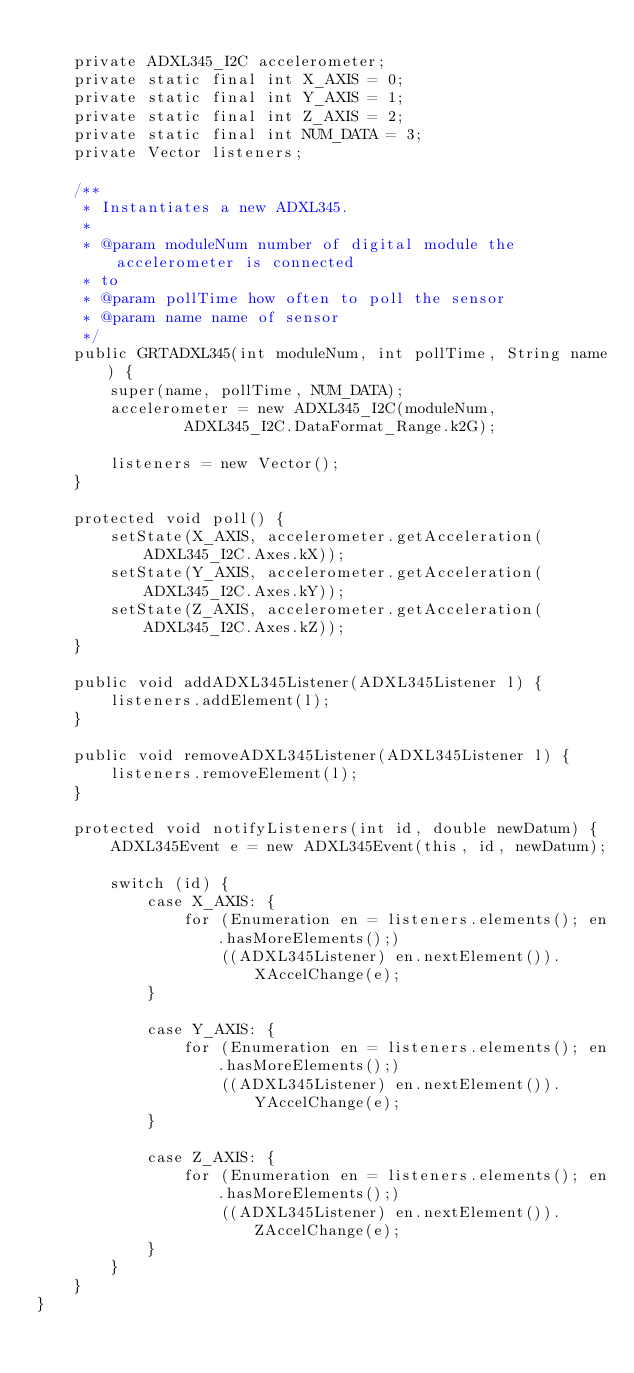<code> <loc_0><loc_0><loc_500><loc_500><_Java_>
    private ADXL345_I2C accelerometer;
    private static final int X_AXIS = 0;
    private static final int Y_AXIS = 1;
    private static final int Z_AXIS = 2;
    private static final int NUM_DATA = 3;
    private Vector listeners;

    /**
     * Instantiates a new ADXL345.
     *
     * @param moduleNum number of digital module the accelerometer is connected
     * to
     * @param pollTime how often to poll the sensor
     * @param name name of sensor
     */
    public GRTADXL345(int moduleNum, int pollTime, String name) {
        super(name, pollTime, NUM_DATA);
        accelerometer = new ADXL345_I2C(moduleNum,
                ADXL345_I2C.DataFormat_Range.k2G);

        listeners = new Vector();
    }

    protected void poll() {
        setState(X_AXIS, accelerometer.getAcceleration(ADXL345_I2C.Axes.kX));
        setState(Y_AXIS, accelerometer.getAcceleration(ADXL345_I2C.Axes.kY));
        setState(Z_AXIS, accelerometer.getAcceleration(ADXL345_I2C.Axes.kZ));
    }

    public void addADXL345Listener(ADXL345Listener l) {
        listeners.addElement(l);
    }

    public void removeADXL345Listener(ADXL345Listener l) {
        listeners.removeElement(l);
    }

    protected void notifyListeners(int id, double newDatum) {
        ADXL345Event e = new ADXL345Event(this, id, newDatum);

        switch (id) {
            case X_AXIS: {
                for (Enumeration en = listeners.elements(); en.hasMoreElements();)
                    ((ADXL345Listener) en.nextElement()).XAccelChange(e);
            }

            case Y_AXIS: {
                for (Enumeration en = listeners.elements(); en.hasMoreElements();)
                    ((ADXL345Listener) en.nextElement()).YAccelChange(e);
            }

            case Z_AXIS: {
                for (Enumeration en = listeners.elements(); en.hasMoreElements();)
                    ((ADXL345Listener) en.nextElement()).ZAccelChange(e);
            }
        }
    }
}
</code> 